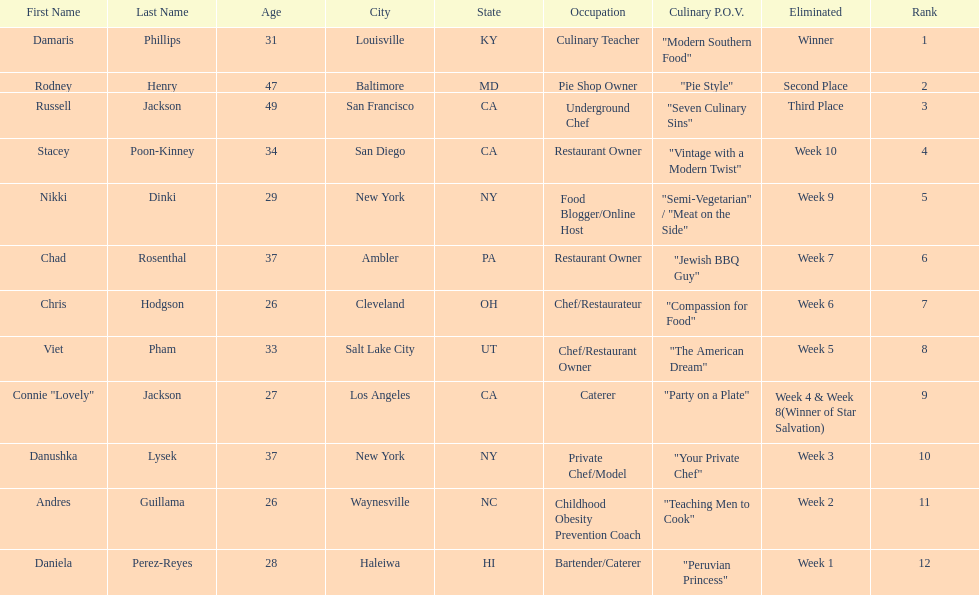Who was the first contestant to be eliminated on season 9 of food network star? Daniela Perez-Reyes. 